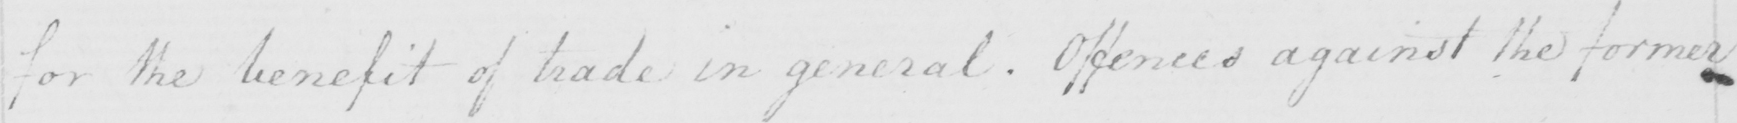Please transcribe the handwritten text in this image. for the benefit of trade in general . Offences against the former 